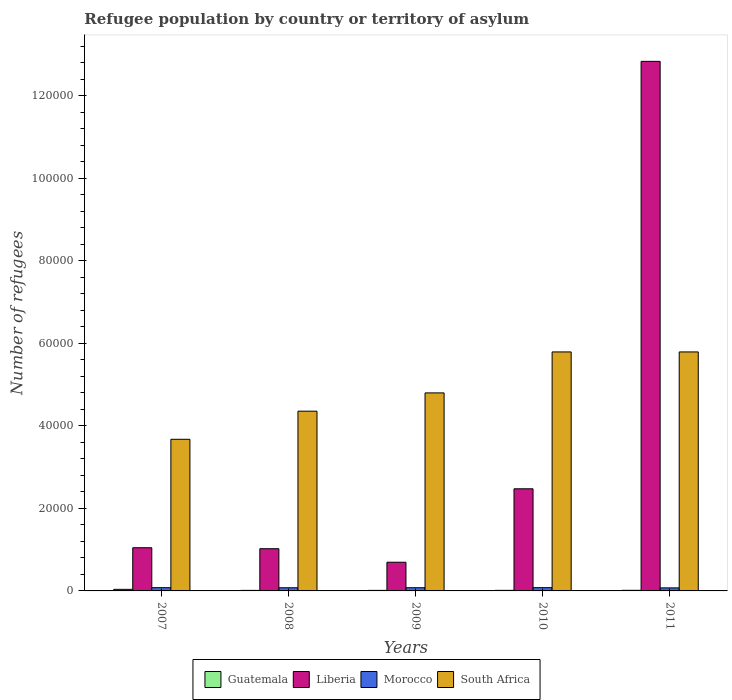How many groups of bars are there?
Make the answer very short. 5. Are the number of bars per tick equal to the number of legend labels?
Keep it short and to the point. Yes. How many bars are there on the 4th tick from the left?
Offer a very short reply. 4. In how many cases, is the number of bars for a given year not equal to the number of legend labels?
Ensure brevity in your answer.  0. What is the number of refugees in Liberia in 2007?
Give a very brief answer. 1.05e+04. Across all years, what is the maximum number of refugees in Liberia?
Offer a very short reply. 1.28e+05. Across all years, what is the minimum number of refugees in South Africa?
Your answer should be very brief. 3.67e+04. In which year was the number of refugees in Morocco minimum?
Make the answer very short. 2011. What is the total number of refugees in Liberia in the graph?
Offer a very short reply. 1.81e+05. What is the difference between the number of refugees in Liberia in 2007 and that in 2010?
Offer a terse response. -1.43e+04. What is the difference between the number of refugees in Morocco in 2010 and the number of refugees in Liberia in 2009?
Your answer should be very brief. -6160. What is the average number of refugees in Morocco per year?
Offer a terse response. 770.6. In the year 2010, what is the difference between the number of refugees in Liberia and number of refugees in South Africa?
Make the answer very short. -3.32e+04. What is the ratio of the number of refugees in Morocco in 2010 to that in 2011?
Give a very brief answer. 1.08. Is the number of refugees in Guatemala in 2010 less than that in 2011?
Your answer should be compact. Yes. Is the difference between the number of refugees in Liberia in 2007 and 2011 greater than the difference between the number of refugees in South Africa in 2007 and 2011?
Give a very brief answer. No. What is the difference between the highest and the second highest number of refugees in South Africa?
Your answer should be very brief. 0. What is the difference between the highest and the lowest number of refugees in Liberia?
Your answer should be compact. 1.21e+05. Is the sum of the number of refugees in Liberia in 2007 and 2011 greater than the maximum number of refugees in Guatemala across all years?
Provide a short and direct response. Yes. What does the 3rd bar from the left in 2010 represents?
Provide a succinct answer. Morocco. What does the 3rd bar from the right in 2007 represents?
Offer a very short reply. Liberia. How many bars are there?
Make the answer very short. 20. Does the graph contain any zero values?
Give a very brief answer. No. Does the graph contain grids?
Provide a succinct answer. No. How are the legend labels stacked?
Your answer should be compact. Horizontal. What is the title of the graph?
Make the answer very short. Refugee population by country or territory of asylum. What is the label or title of the X-axis?
Your response must be concise. Years. What is the label or title of the Y-axis?
Offer a terse response. Number of refugees. What is the Number of refugees of Guatemala in 2007?
Offer a terse response. 379. What is the Number of refugees of Liberia in 2007?
Your response must be concise. 1.05e+04. What is the Number of refugees in Morocco in 2007?
Make the answer very short. 786. What is the Number of refugees in South Africa in 2007?
Offer a very short reply. 3.67e+04. What is the Number of refugees of Guatemala in 2008?
Make the answer very short. 130. What is the Number of refugees in Liberia in 2008?
Offer a very short reply. 1.02e+04. What is the Number of refugees in Morocco in 2008?
Your answer should be very brief. 766. What is the Number of refugees in South Africa in 2008?
Offer a terse response. 4.35e+04. What is the Number of refugees in Guatemala in 2009?
Ensure brevity in your answer.  131. What is the Number of refugees in Liberia in 2009?
Offer a very short reply. 6952. What is the Number of refugees in Morocco in 2009?
Ensure brevity in your answer.  773. What is the Number of refugees in South Africa in 2009?
Offer a terse response. 4.80e+04. What is the Number of refugees in Guatemala in 2010?
Ensure brevity in your answer.  138. What is the Number of refugees of Liberia in 2010?
Provide a short and direct response. 2.47e+04. What is the Number of refugees in Morocco in 2010?
Offer a terse response. 792. What is the Number of refugees in South Africa in 2010?
Give a very brief answer. 5.79e+04. What is the Number of refugees of Guatemala in 2011?
Offer a very short reply. 147. What is the Number of refugees in Liberia in 2011?
Provide a short and direct response. 1.28e+05. What is the Number of refugees of Morocco in 2011?
Provide a short and direct response. 736. What is the Number of refugees in South Africa in 2011?
Keep it short and to the point. 5.79e+04. Across all years, what is the maximum Number of refugees in Guatemala?
Ensure brevity in your answer.  379. Across all years, what is the maximum Number of refugees of Liberia?
Provide a succinct answer. 1.28e+05. Across all years, what is the maximum Number of refugees in Morocco?
Your response must be concise. 792. Across all years, what is the maximum Number of refugees of South Africa?
Offer a terse response. 5.79e+04. Across all years, what is the minimum Number of refugees of Guatemala?
Make the answer very short. 130. Across all years, what is the minimum Number of refugees of Liberia?
Ensure brevity in your answer.  6952. Across all years, what is the minimum Number of refugees in Morocco?
Your answer should be compact. 736. Across all years, what is the minimum Number of refugees in South Africa?
Your answer should be compact. 3.67e+04. What is the total Number of refugees in Guatemala in the graph?
Make the answer very short. 925. What is the total Number of refugees of Liberia in the graph?
Your response must be concise. 1.81e+05. What is the total Number of refugees in Morocco in the graph?
Give a very brief answer. 3853. What is the total Number of refugees in South Africa in the graph?
Give a very brief answer. 2.44e+05. What is the difference between the Number of refugees in Guatemala in 2007 and that in 2008?
Provide a succinct answer. 249. What is the difference between the Number of refugees in Liberia in 2007 and that in 2008?
Offer a terse response. 242. What is the difference between the Number of refugees of Morocco in 2007 and that in 2008?
Provide a short and direct response. 20. What is the difference between the Number of refugees of South Africa in 2007 and that in 2008?
Provide a succinct answer. -6810. What is the difference between the Number of refugees in Guatemala in 2007 and that in 2009?
Ensure brevity in your answer.  248. What is the difference between the Number of refugees in Liberia in 2007 and that in 2009?
Your response must be concise. 3514. What is the difference between the Number of refugees of Morocco in 2007 and that in 2009?
Provide a succinct answer. 13. What is the difference between the Number of refugees in South Africa in 2007 and that in 2009?
Keep it short and to the point. -1.12e+04. What is the difference between the Number of refugees in Guatemala in 2007 and that in 2010?
Keep it short and to the point. 241. What is the difference between the Number of refugees of Liberia in 2007 and that in 2010?
Provide a succinct answer. -1.43e+04. What is the difference between the Number of refugees in South Africa in 2007 and that in 2010?
Offer a very short reply. -2.12e+04. What is the difference between the Number of refugees in Guatemala in 2007 and that in 2011?
Offer a very short reply. 232. What is the difference between the Number of refugees in Liberia in 2007 and that in 2011?
Offer a very short reply. -1.18e+05. What is the difference between the Number of refugees of South Africa in 2007 and that in 2011?
Your answer should be compact. -2.12e+04. What is the difference between the Number of refugees in Liberia in 2008 and that in 2009?
Give a very brief answer. 3272. What is the difference between the Number of refugees in South Africa in 2008 and that in 2009?
Your answer should be very brief. -4428. What is the difference between the Number of refugees in Liberia in 2008 and that in 2010?
Your response must be concise. -1.45e+04. What is the difference between the Number of refugees in Morocco in 2008 and that in 2010?
Give a very brief answer. -26. What is the difference between the Number of refugees in South Africa in 2008 and that in 2010?
Your answer should be very brief. -1.44e+04. What is the difference between the Number of refugees of Guatemala in 2008 and that in 2011?
Provide a succinct answer. -17. What is the difference between the Number of refugees in Liberia in 2008 and that in 2011?
Your answer should be compact. -1.18e+05. What is the difference between the Number of refugees of Morocco in 2008 and that in 2011?
Offer a terse response. 30. What is the difference between the Number of refugees in South Africa in 2008 and that in 2011?
Your answer should be very brief. -1.44e+04. What is the difference between the Number of refugees in Liberia in 2009 and that in 2010?
Offer a terse response. -1.78e+04. What is the difference between the Number of refugees in South Africa in 2009 and that in 2010?
Your answer should be compact. -9925. What is the difference between the Number of refugees of Guatemala in 2009 and that in 2011?
Offer a terse response. -16. What is the difference between the Number of refugees of Liberia in 2009 and that in 2011?
Keep it short and to the point. -1.21e+05. What is the difference between the Number of refugees in Morocco in 2009 and that in 2011?
Your answer should be compact. 37. What is the difference between the Number of refugees in South Africa in 2009 and that in 2011?
Your answer should be very brief. -9925. What is the difference between the Number of refugees in Guatemala in 2010 and that in 2011?
Give a very brief answer. -9. What is the difference between the Number of refugees of Liberia in 2010 and that in 2011?
Ensure brevity in your answer.  -1.04e+05. What is the difference between the Number of refugees in Morocco in 2010 and that in 2011?
Your answer should be very brief. 56. What is the difference between the Number of refugees in South Africa in 2010 and that in 2011?
Offer a very short reply. 0. What is the difference between the Number of refugees in Guatemala in 2007 and the Number of refugees in Liberia in 2008?
Your answer should be very brief. -9845. What is the difference between the Number of refugees of Guatemala in 2007 and the Number of refugees of Morocco in 2008?
Offer a terse response. -387. What is the difference between the Number of refugees of Guatemala in 2007 and the Number of refugees of South Africa in 2008?
Make the answer very short. -4.32e+04. What is the difference between the Number of refugees of Liberia in 2007 and the Number of refugees of Morocco in 2008?
Offer a terse response. 9700. What is the difference between the Number of refugees in Liberia in 2007 and the Number of refugees in South Africa in 2008?
Provide a succinct answer. -3.31e+04. What is the difference between the Number of refugees of Morocco in 2007 and the Number of refugees of South Africa in 2008?
Ensure brevity in your answer.  -4.28e+04. What is the difference between the Number of refugees in Guatemala in 2007 and the Number of refugees in Liberia in 2009?
Ensure brevity in your answer.  -6573. What is the difference between the Number of refugees of Guatemala in 2007 and the Number of refugees of Morocco in 2009?
Make the answer very short. -394. What is the difference between the Number of refugees in Guatemala in 2007 and the Number of refugees in South Africa in 2009?
Keep it short and to the point. -4.76e+04. What is the difference between the Number of refugees of Liberia in 2007 and the Number of refugees of Morocco in 2009?
Keep it short and to the point. 9693. What is the difference between the Number of refugees of Liberia in 2007 and the Number of refugees of South Africa in 2009?
Offer a very short reply. -3.75e+04. What is the difference between the Number of refugees of Morocco in 2007 and the Number of refugees of South Africa in 2009?
Make the answer very short. -4.72e+04. What is the difference between the Number of refugees of Guatemala in 2007 and the Number of refugees of Liberia in 2010?
Keep it short and to the point. -2.44e+04. What is the difference between the Number of refugees in Guatemala in 2007 and the Number of refugees in Morocco in 2010?
Make the answer very short. -413. What is the difference between the Number of refugees in Guatemala in 2007 and the Number of refugees in South Africa in 2010?
Offer a terse response. -5.75e+04. What is the difference between the Number of refugees of Liberia in 2007 and the Number of refugees of Morocco in 2010?
Give a very brief answer. 9674. What is the difference between the Number of refugees in Liberia in 2007 and the Number of refugees in South Africa in 2010?
Your response must be concise. -4.74e+04. What is the difference between the Number of refugees in Morocco in 2007 and the Number of refugees in South Africa in 2010?
Your response must be concise. -5.71e+04. What is the difference between the Number of refugees in Guatemala in 2007 and the Number of refugees in Liberia in 2011?
Your answer should be compact. -1.28e+05. What is the difference between the Number of refugees in Guatemala in 2007 and the Number of refugees in Morocco in 2011?
Your response must be concise. -357. What is the difference between the Number of refugees of Guatemala in 2007 and the Number of refugees of South Africa in 2011?
Your answer should be very brief. -5.75e+04. What is the difference between the Number of refugees in Liberia in 2007 and the Number of refugees in Morocco in 2011?
Keep it short and to the point. 9730. What is the difference between the Number of refugees in Liberia in 2007 and the Number of refugees in South Africa in 2011?
Make the answer very short. -4.74e+04. What is the difference between the Number of refugees in Morocco in 2007 and the Number of refugees in South Africa in 2011?
Ensure brevity in your answer.  -5.71e+04. What is the difference between the Number of refugees in Guatemala in 2008 and the Number of refugees in Liberia in 2009?
Ensure brevity in your answer.  -6822. What is the difference between the Number of refugees in Guatemala in 2008 and the Number of refugees in Morocco in 2009?
Offer a terse response. -643. What is the difference between the Number of refugees of Guatemala in 2008 and the Number of refugees of South Africa in 2009?
Your response must be concise. -4.78e+04. What is the difference between the Number of refugees of Liberia in 2008 and the Number of refugees of Morocco in 2009?
Keep it short and to the point. 9451. What is the difference between the Number of refugees in Liberia in 2008 and the Number of refugees in South Africa in 2009?
Provide a short and direct response. -3.78e+04. What is the difference between the Number of refugees in Morocco in 2008 and the Number of refugees in South Africa in 2009?
Make the answer very short. -4.72e+04. What is the difference between the Number of refugees in Guatemala in 2008 and the Number of refugees in Liberia in 2010?
Offer a terse response. -2.46e+04. What is the difference between the Number of refugees of Guatemala in 2008 and the Number of refugees of Morocco in 2010?
Your response must be concise. -662. What is the difference between the Number of refugees of Guatemala in 2008 and the Number of refugees of South Africa in 2010?
Give a very brief answer. -5.78e+04. What is the difference between the Number of refugees in Liberia in 2008 and the Number of refugees in Morocco in 2010?
Offer a very short reply. 9432. What is the difference between the Number of refugees in Liberia in 2008 and the Number of refugees in South Africa in 2010?
Keep it short and to the point. -4.77e+04. What is the difference between the Number of refugees of Morocco in 2008 and the Number of refugees of South Africa in 2010?
Offer a very short reply. -5.71e+04. What is the difference between the Number of refugees in Guatemala in 2008 and the Number of refugees in Liberia in 2011?
Offer a very short reply. -1.28e+05. What is the difference between the Number of refugees in Guatemala in 2008 and the Number of refugees in Morocco in 2011?
Give a very brief answer. -606. What is the difference between the Number of refugees of Guatemala in 2008 and the Number of refugees of South Africa in 2011?
Your answer should be compact. -5.78e+04. What is the difference between the Number of refugees of Liberia in 2008 and the Number of refugees of Morocco in 2011?
Keep it short and to the point. 9488. What is the difference between the Number of refugees in Liberia in 2008 and the Number of refugees in South Africa in 2011?
Your answer should be very brief. -4.77e+04. What is the difference between the Number of refugees in Morocco in 2008 and the Number of refugees in South Africa in 2011?
Keep it short and to the point. -5.71e+04. What is the difference between the Number of refugees in Guatemala in 2009 and the Number of refugees in Liberia in 2010?
Offer a very short reply. -2.46e+04. What is the difference between the Number of refugees of Guatemala in 2009 and the Number of refugees of Morocco in 2010?
Your answer should be compact. -661. What is the difference between the Number of refugees in Guatemala in 2009 and the Number of refugees in South Africa in 2010?
Offer a very short reply. -5.78e+04. What is the difference between the Number of refugees of Liberia in 2009 and the Number of refugees of Morocco in 2010?
Your answer should be compact. 6160. What is the difference between the Number of refugees in Liberia in 2009 and the Number of refugees in South Africa in 2010?
Provide a succinct answer. -5.09e+04. What is the difference between the Number of refugees of Morocco in 2009 and the Number of refugees of South Africa in 2010?
Your answer should be compact. -5.71e+04. What is the difference between the Number of refugees of Guatemala in 2009 and the Number of refugees of Liberia in 2011?
Offer a terse response. -1.28e+05. What is the difference between the Number of refugees in Guatemala in 2009 and the Number of refugees in Morocco in 2011?
Provide a short and direct response. -605. What is the difference between the Number of refugees in Guatemala in 2009 and the Number of refugees in South Africa in 2011?
Offer a terse response. -5.78e+04. What is the difference between the Number of refugees of Liberia in 2009 and the Number of refugees of Morocco in 2011?
Offer a terse response. 6216. What is the difference between the Number of refugees of Liberia in 2009 and the Number of refugees of South Africa in 2011?
Your response must be concise. -5.09e+04. What is the difference between the Number of refugees of Morocco in 2009 and the Number of refugees of South Africa in 2011?
Keep it short and to the point. -5.71e+04. What is the difference between the Number of refugees in Guatemala in 2010 and the Number of refugees in Liberia in 2011?
Give a very brief answer. -1.28e+05. What is the difference between the Number of refugees of Guatemala in 2010 and the Number of refugees of Morocco in 2011?
Ensure brevity in your answer.  -598. What is the difference between the Number of refugees in Guatemala in 2010 and the Number of refugees in South Africa in 2011?
Offer a very short reply. -5.78e+04. What is the difference between the Number of refugees in Liberia in 2010 and the Number of refugees in Morocco in 2011?
Keep it short and to the point. 2.40e+04. What is the difference between the Number of refugees in Liberia in 2010 and the Number of refugees in South Africa in 2011?
Provide a short and direct response. -3.32e+04. What is the difference between the Number of refugees in Morocco in 2010 and the Number of refugees in South Africa in 2011?
Provide a short and direct response. -5.71e+04. What is the average Number of refugees in Guatemala per year?
Keep it short and to the point. 185. What is the average Number of refugees in Liberia per year?
Offer a very short reply. 3.61e+04. What is the average Number of refugees of Morocco per year?
Keep it short and to the point. 770.6. What is the average Number of refugees of South Africa per year?
Provide a succinct answer. 4.88e+04. In the year 2007, what is the difference between the Number of refugees of Guatemala and Number of refugees of Liberia?
Provide a short and direct response. -1.01e+04. In the year 2007, what is the difference between the Number of refugees of Guatemala and Number of refugees of Morocco?
Your answer should be very brief. -407. In the year 2007, what is the difference between the Number of refugees of Guatemala and Number of refugees of South Africa?
Make the answer very short. -3.64e+04. In the year 2007, what is the difference between the Number of refugees of Liberia and Number of refugees of Morocco?
Make the answer very short. 9680. In the year 2007, what is the difference between the Number of refugees in Liberia and Number of refugees in South Africa?
Your answer should be compact. -2.63e+04. In the year 2007, what is the difference between the Number of refugees of Morocco and Number of refugees of South Africa?
Keep it short and to the point. -3.60e+04. In the year 2008, what is the difference between the Number of refugees in Guatemala and Number of refugees in Liberia?
Provide a short and direct response. -1.01e+04. In the year 2008, what is the difference between the Number of refugees of Guatemala and Number of refugees of Morocco?
Make the answer very short. -636. In the year 2008, what is the difference between the Number of refugees of Guatemala and Number of refugees of South Africa?
Give a very brief answer. -4.34e+04. In the year 2008, what is the difference between the Number of refugees of Liberia and Number of refugees of Morocco?
Provide a short and direct response. 9458. In the year 2008, what is the difference between the Number of refugees of Liberia and Number of refugees of South Africa?
Provide a succinct answer. -3.33e+04. In the year 2008, what is the difference between the Number of refugees of Morocco and Number of refugees of South Africa?
Provide a short and direct response. -4.28e+04. In the year 2009, what is the difference between the Number of refugees of Guatemala and Number of refugees of Liberia?
Your answer should be very brief. -6821. In the year 2009, what is the difference between the Number of refugees of Guatemala and Number of refugees of Morocco?
Your answer should be compact. -642. In the year 2009, what is the difference between the Number of refugees of Guatemala and Number of refugees of South Africa?
Ensure brevity in your answer.  -4.78e+04. In the year 2009, what is the difference between the Number of refugees of Liberia and Number of refugees of Morocco?
Your answer should be compact. 6179. In the year 2009, what is the difference between the Number of refugees of Liberia and Number of refugees of South Africa?
Keep it short and to the point. -4.10e+04. In the year 2009, what is the difference between the Number of refugees in Morocco and Number of refugees in South Africa?
Provide a short and direct response. -4.72e+04. In the year 2010, what is the difference between the Number of refugees in Guatemala and Number of refugees in Liberia?
Give a very brief answer. -2.46e+04. In the year 2010, what is the difference between the Number of refugees of Guatemala and Number of refugees of Morocco?
Provide a short and direct response. -654. In the year 2010, what is the difference between the Number of refugees in Guatemala and Number of refugees in South Africa?
Ensure brevity in your answer.  -5.78e+04. In the year 2010, what is the difference between the Number of refugees in Liberia and Number of refugees in Morocco?
Offer a terse response. 2.40e+04. In the year 2010, what is the difference between the Number of refugees of Liberia and Number of refugees of South Africa?
Keep it short and to the point. -3.32e+04. In the year 2010, what is the difference between the Number of refugees of Morocco and Number of refugees of South Africa?
Give a very brief answer. -5.71e+04. In the year 2011, what is the difference between the Number of refugees in Guatemala and Number of refugees in Liberia?
Offer a terse response. -1.28e+05. In the year 2011, what is the difference between the Number of refugees in Guatemala and Number of refugees in Morocco?
Keep it short and to the point. -589. In the year 2011, what is the difference between the Number of refugees in Guatemala and Number of refugees in South Africa?
Your answer should be very brief. -5.78e+04. In the year 2011, what is the difference between the Number of refugees in Liberia and Number of refugees in Morocco?
Ensure brevity in your answer.  1.28e+05. In the year 2011, what is the difference between the Number of refugees in Liberia and Number of refugees in South Africa?
Make the answer very short. 7.04e+04. In the year 2011, what is the difference between the Number of refugees in Morocco and Number of refugees in South Africa?
Provide a succinct answer. -5.72e+04. What is the ratio of the Number of refugees in Guatemala in 2007 to that in 2008?
Offer a terse response. 2.92. What is the ratio of the Number of refugees of Liberia in 2007 to that in 2008?
Offer a very short reply. 1.02. What is the ratio of the Number of refugees of Morocco in 2007 to that in 2008?
Your response must be concise. 1.03. What is the ratio of the Number of refugees of South Africa in 2007 to that in 2008?
Ensure brevity in your answer.  0.84. What is the ratio of the Number of refugees of Guatemala in 2007 to that in 2009?
Ensure brevity in your answer.  2.89. What is the ratio of the Number of refugees in Liberia in 2007 to that in 2009?
Offer a terse response. 1.51. What is the ratio of the Number of refugees of Morocco in 2007 to that in 2009?
Ensure brevity in your answer.  1.02. What is the ratio of the Number of refugees in South Africa in 2007 to that in 2009?
Your response must be concise. 0.77. What is the ratio of the Number of refugees of Guatemala in 2007 to that in 2010?
Offer a very short reply. 2.75. What is the ratio of the Number of refugees in Liberia in 2007 to that in 2010?
Provide a succinct answer. 0.42. What is the ratio of the Number of refugees of Morocco in 2007 to that in 2010?
Your response must be concise. 0.99. What is the ratio of the Number of refugees in South Africa in 2007 to that in 2010?
Provide a succinct answer. 0.63. What is the ratio of the Number of refugees in Guatemala in 2007 to that in 2011?
Offer a very short reply. 2.58. What is the ratio of the Number of refugees in Liberia in 2007 to that in 2011?
Your answer should be compact. 0.08. What is the ratio of the Number of refugees in Morocco in 2007 to that in 2011?
Offer a very short reply. 1.07. What is the ratio of the Number of refugees in South Africa in 2007 to that in 2011?
Make the answer very short. 0.63. What is the ratio of the Number of refugees of Guatemala in 2008 to that in 2009?
Your answer should be compact. 0.99. What is the ratio of the Number of refugees of Liberia in 2008 to that in 2009?
Give a very brief answer. 1.47. What is the ratio of the Number of refugees of Morocco in 2008 to that in 2009?
Offer a very short reply. 0.99. What is the ratio of the Number of refugees in South Africa in 2008 to that in 2009?
Offer a very short reply. 0.91. What is the ratio of the Number of refugees of Guatemala in 2008 to that in 2010?
Keep it short and to the point. 0.94. What is the ratio of the Number of refugees in Liberia in 2008 to that in 2010?
Keep it short and to the point. 0.41. What is the ratio of the Number of refugees in Morocco in 2008 to that in 2010?
Offer a terse response. 0.97. What is the ratio of the Number of refugees of South Africa in 2008 to that in 2010?
Give a very brief answer. 0.75. What is the ratio of the Number of refugees in Guatemala in 2008 to that in 2011?
Keep it short and to the point. 0.88. What is the ratio of the Number of refugees of Liberia in 2008 to that in 2011?
Provide a succinct answer. 0.08. What is the ratio of the Number of refugees of Morocco in 2008 to that in 2011?
Offer a terse response. 1.04. What is the ratio of the Number of refugees of South Africa in 2008 to that in 2011?
Give a very brief answer. 0.75. What is the ratio of the Number of refugees of Guatemala in 2009 to that in 2010?
Offer a very short reply. 0.95. What is the ratio of the Number of refugees of Liberia in 2009 to that in 2010?
Your answer should be very brief. 0.28. What is the ratio of the Number of refugees of South Africa in 2009 to that in 2010?
Provide a short and direct response. 0.83. What is the ratio of the Number of refugees of Guatemala in 2009 to that in 2011?
Keep it short and to the point. 0.89. What is the ratio of the Number of refugees of Liberia in 2009 to that in 2011?
Your response must be concise. 0.05. What is the ratio of the Number of refugees in Morocco in 2009 to that in 2011?
Your answer should be compact. 1.05. What is the ratio of the Number of refugees in South Africa in 2009 to that in 2011?
Offer a terse response. 0.83. What is the ratio of the Number of refugees in Guatemala in 2010 to that in 2011?
Your answer should be very brief. 0.94. What is the ratio of the Number of refugees in Liberia in 2010 to that in 2011?
Ensure brevity in your answer.  0.19. What is the ratio of the Number of refugees of Morocco in 2010 to that in 2011?
Keep it short and to the point. 1.08. What is the difference between the highest and the second highest Number of refugees in Guatemala?
Provide a succinct answer. 232. What is the difference between the highest and the second highest Number of refugees of Liberia?
Your answer should be very brief. 1.04e+05. What is the difference between the highest and the second highest Number of refugees of Morocco?
Your response must be concise. 6. What is the difference between the highest and the lowest Number of refugees in Guatemala?
Make the answer very short. 249. What is the difference between the highest and the lowest Number of refugees in Liberia?
Keep it short and to the point. 1.21e+05. What is the difference between the highest and the lowest Number of refugees of Morocco?
Your answer should be compact. 56. What is the difference between the highest and the lowest Number of refugees of South Africa?
Offer a terse response. 2.12e+04. 